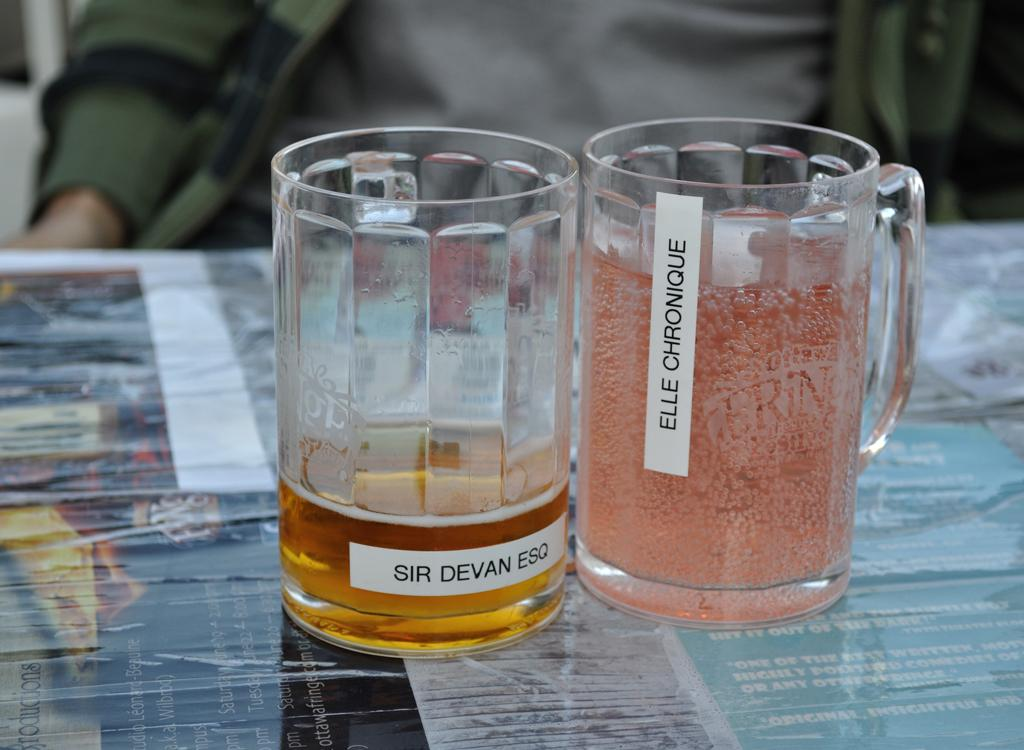Provide a one-sentence caption for the provided image. A full beverage glass with Elle Chronique on it next to an almost empty beverage glass with Sir Devan Esq on it. 